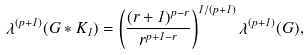<formula> <loc_0><loc_0><loc_500><loc_500>\lambda ^ { ( p + 1 ) } ( G * K _ { 1 } ) = \left ( \frac { ( r + 1 ) ^ { p - r } } { r ^ { p + 1 - r } } \right ) ^ { 1 / ( p + 1 ) } \lambda ^ { ( p + 1 ) } ( G ) ,</formula> 